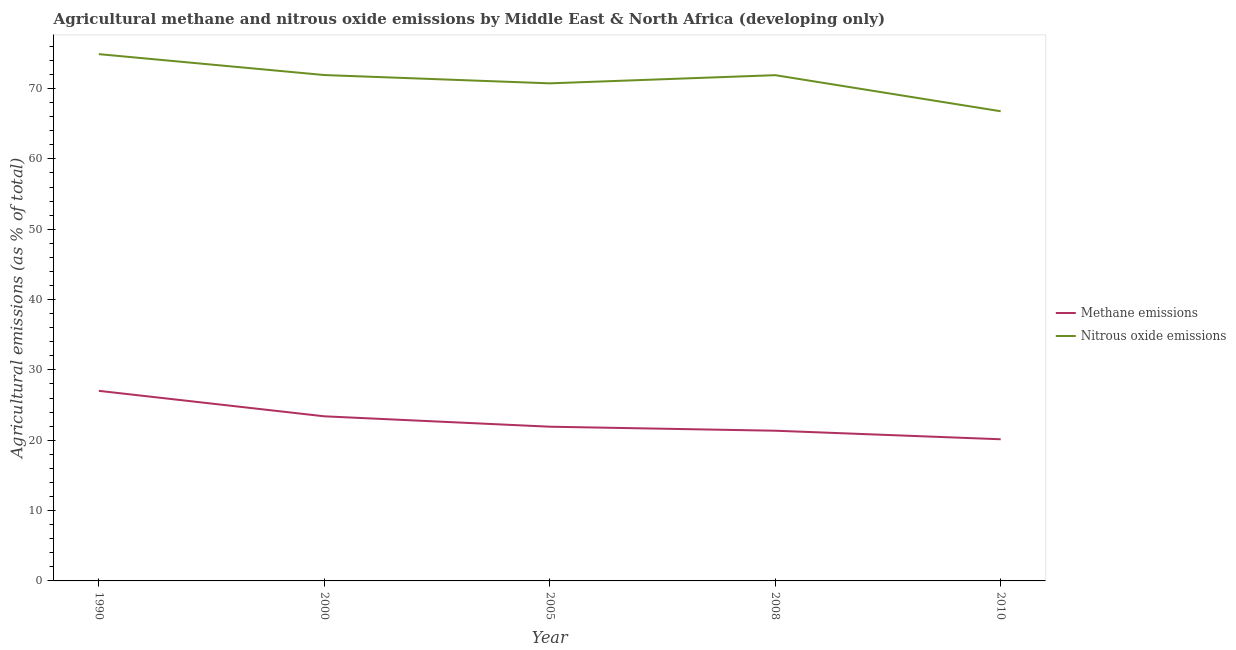How many different coloured lines are there?
Provide a short and direct response. 2. Is the number of lines equal to the number of legend labels?
Ensure brevity in your answer.  Yes. What is the amount of nitrous oxide emissions in 2008?
Ensure brevity in your answer.  71.9. Across all years, what is the maximum amount of nitrous oxide emissions?
Your answer should be compact. 74.9. Across all years, what is the minimum amount of methane emissions?
Ensure brevity in your answer.  20.14. What is the total amount of methane emissions in the graph?
Provide a short and direct response. 113.85. What is the difference between the amount of methane emissions in 2005 and that in 2008?
Ensure brevity in your answer.  0.57. What is the difference between the amount of methane emissions in 2010 and the amount of nitrous oxide emissions in 1990?
Ensure brevity in your answer.  -54.76. What is the average amount of methane emissions per year?
Ensure brevity in your answer.  22.77. In the year 2000, what is the difference between the amount of nitrous oxide emissions and amount of methane emissions?
Keep it short and to the point. 48.52. In how many years, is the amount of nitrous oxide emissions greater than 44 %?
Offer a very short reply. 5. What is the ratio of the amount of nitrous oxide emissions in 2000 to that in 2008?
Your answer should be very brief. 1. What is the difference between the highest and the second highest amount of nitrous oxide emissions?
Ensure brevity in your answer.  2.97. What is the difference between the highest and the lowest amount of methane emissions?
Offer a very short reply. 6.89. In how many years, is the amount of nitrous oxide emissions greater than the average amount of nitrous oxide emissions taken over all years?
Provide a succinct answer. 3. Is the amount of methane emissions strictly greater than the amount of nitrous oxide emissions over the years?
Keep it short and to the point. No. Is the amount of nitrous oxide emissions strictly less than the amount of methane emissions over the years?
Make the answer very short. No. How many lines are there?
Your response must be concise. 2. How many years are there in the graph?
Keep it short and to the point. 5. What is the difference between two consecutive major ticks on the Y-axis?
Provide a succinct answer. 10. Does the graph contain grids?
Provide a short and direct response. No. How are the legend labels stacked?
Keep it short and to the point. Vertical. What is the title of the graph?
Give a very brief answer. Agricultural methane and nitrous oxide emissions by Middle East & North Africa (developing only). Does "UN agencies" appear as one of the legend labels in the graph?
Make the answer very short. No. What is the label or title of the X-axis?
Your answer should be compact. Year. What is the label or title of the Y-axis?
Your answer should be very brief. Agricultural emissions (as % of total). What is the Agricultural emissions (as % of total) in Methane emissions in 1990?
Your response must be concise. 27.03. What is the Agricultural emissions (as % of total) of Nitrous oxide emissions in 1990?
Give a very brief answer. 74.9. What is the Agricultural emissions (as % of total) in Methane emissions in 2000?
Offer a very short reply. 23.4. What is the Agricultural emissions (as % of total) in Nitrous oxide emissions in 2000?
Ensure brevity in your answer.  71.92. What is the Agricultural emissions (as % of total) of Methane emissions in 2005?
Your answer should be very brief. 21.93. What is the Agricultural emissions (as % of total) in Nitrous oxide emissions in 2005?
Ensure brevity in your answer.  70.74. What is the Agricultural emissions (as % of total) of Methane emissions in 2008?
Ensure brevity in your answer.  21.36. What is the Agricultural emissions (as % of total) in Nitrous oxide emissions in 2008?
Keep it short and to the point. 71.9. What is the Agricultural emissions (as % of total) in Methane emissions in 2010?
Make the answer very short. 20.14. What is the Agricultural emissions (as % of total) in Nitrous oxide emissions in 2010?
Give a very brief answer. 66.77. Across all years, what is the maximum Agricultural emissions (as % of total) of Methane emissions?
Offer a very short reply. 27.03. Across all years, what is the maximum Agricultural emissions (as % of total) in Nitrous oxide emissions?
Provide a succinct answer. 74.9. Across all years, what is the minimum Agricultural emissions (as % of total) in Methane emissions?
Make the answer very short. 20.14. Across all years, what is the minimum Agricultural emissions (as % of total) in Nitrous oxide emissions?
Offer a terse response. 66.77. What is the total Agricultural emissions (as % of total) of Methane emissions in the graph?
Provide a short and direct response. 113.85. What is the total Agricultural emissions (as % of total) in Nitrous oxide emissions in the graph?
Ensure brevity in your answer.  356.24. What is the difference between the Agricultural emissions (as % of total) in Methane emissions in 1990 and that in 2000?
Your answer should be very brief. 3.62. What is the difference between the Agricultural emissions (as % of total) of Nitrous oxide emissions in 1990 and that in 2000?
Provide a succinct answer. 2.97. What is the difference between the Agricultural emissions (as % of total) of Methane emissions in 1990 and that in 2005?
Your answer should be compact. 5.1. What is the difference between the Agricultural emissions (as % of total) of Nitrous oxide emissions in 1990 and that in 2005?
Your answer should be very brief. 4.15. What is the difference between the Agricultural emissions (as % of total) in Methane emissions in 1990 and that in 2008?
Your response must be concise. 5.67. What is the difference between the Agricultural emissions (as % of total) of Nitrous oxide emissions in 1990 and that in 2008?
Provide a succinct answer. 2.99. What is the difference between the Agricultural emissions (as % of total) in Methane emissions in 1990 and that in 2010?
Your answer should be compact. 6.89. What is the difference between the Agricultural emissions (as % of total) in Nitrous oxide emissions in 1990 and that in 2010?
Your answer should be compact. 8.12. What is the difference between the Agricultural emissions (as % of total) in Methane emissions in 2000 and that in 2005?
Make the answer very short. 1.48. What is the difference between the Agricultural emissions (as % of total) of Nitrous oxide emissions in 2000 and that in 2005?
Keep it short and to the point. 1.18. What is the difference between the Agricultural emissions (as % of total) of Methane emissions in 2000 and that in 2008?
Your answer should be very brief. 2.05. What is the difference between the Agricultural emissions (as % of total) in Nitrous oxide emissions in 2000 and that in 2008?
Provide a short and direct response. 0.02. What is the difference between the Agricultural emissions (as % of total) in Methane emissions in 2000 and that in 2010?
Your response must be concise. 3.26. What is the difference between the Agricultural emissions (as % of total) of Nitrous oxide emissions in 2000 and that in 2010?
Ensure brevity in your answer.  5.15. What is the difference between the Agricultural emissions (as % of total) of Methane emissions in 2005 and that in 2008?
Provide a succinct answer. 0.57. What is the difference between the Agricultural emissions (as % of total) in Nitrous oxide emissions in 2005 and that in 2008?
Give a very brief answer. -1.16. What is the difference between the Agricultural emissions (as % of total) of Methane emissions in 2005 and that in 2010?
Provide a short and direct response. 1.79. What is the difference between the Agricultural emissions (as % of total) in Nitrous oxide emissions in 2005 and that in 2010?
Keep it short and to the point. 3.97. What is the difference between the Agricultural emissions (as % of total) of Methane emissions in 2008 and that in 2010?
Keep it short and to the point. 1.22. What is the difference between the Agricultural emissions (as % of total) in Nitrous oxide emissions in 2008 and that in 2010?
Provide a short and direct response. 5.13. What is the difference between the Agricultural emissions (as % of total) of Methane emissions in 1990 and the Agricultural emissions (as % of total) of Nitrous oxide emissions in 2000?
Offer a terse response. -44.9. What is the difference between the Agricultural emissions (as % of total) in Methane emissions in 1990 and the Agricultural emissions (as % of total) in Nitrous oxide emissions in 2005?
Provide a succinct answer. -43.72. What is the difference between the Agricultural emissions (as % of total) of Methane emissions in 1990 and the Agricultural emissions (as % of total) of Nitrous oxide emissions in 2008?
Provide a short and direct response. -44.88. What is the difference between the Agricultural emissions (as % of total) in Methane emissions in 1990 and the Agricultural emissions (as % of total) in Nitrous oxide emissions in 2010?
Your answer should be compact. -39.75. What is the difference between the Agricultural emissions (as % of total) of Methane emissions in 2000 and the Agricultural emissions (as % of total) of Nitrous oxide emissions in 2005?
Keep it short and to the point. -47.34. What is the difference between the Agricultural emissions (as % of total) of Methane emissions in 2000 and the Agricultural emissions (as % of total) of Nitrous oxide emissions in 2008?
Keep it short and to the point. -48.5. What is the difference between the Agricultural emissions (as % of total) in Methane emissions in 2000 and the Agricultural emissions (as % of total) in Nitrous oxide emissions in 2010?
Offer a very short reply. -43.37. What is the difference between the Agricultural emissions (as % of total) of Methane emissions in 2005 and the Agricultural emissions (as % of total) of Nitrous oxide emissions in 2008?
Your answer should be very brief. -49.98. What is the difference between the Agricultural emissions (as % of total) in Methane emissions in 2005 and the Agricultural emissions (as % of total) in Nitrous oxide emissions in 2010?
Give a very brief answer. -44.85. What is the difference between the Agricultural emissions (as % of total) in Methane emissions in 2008 and the Agricultural emissions (as % of total) in Nitrous oxide emissions in 2010?
Keep it short and to the point. -45.42. What is the average Agricultural emissions (as % of total) of Methane emissions per year?
Offer a terse response. 22.77. What is the average Agricultural emissions (as % of total) in Nitrous oxide emissions per year?
Your answer should be compact. 71.25. In the year 1990, what is the difference between the Agricultural emissions (as % of total) of Methane emissions and Agricultural emissions (as % of total) of Nitrous oxide emissions?
Provide a short and direct response. -47.87. In the year 2000, what is the difference between the Agricultural emissions (as % of total) of Methane emissions and Agricultural emissions (as % of total) of Nitrous oxide emissions?
Your answer should be very brief. -48.52. In the year 2005, what is the difference between the Agricultural emissions (as % of total) of Methane emissions and Agricultural emissions (as % of total) of Nitrous oxide emissions?
Provide a succinct answer. -48.82. In the year 2008, what is the difference between the Agricultural emissions (as % of total) in Methane emissions and Agricultural emissions (as % of total) in Nitrous oxide emissions?
Your response must be concise. -50.55. In the year 2010, what is the difference between the Agricultural emissions (as % of total) in Methane emissions and Agricultural emissions (as % of total) in Nitrous oxide emissions?
Your response must be concise. -46.63. What is the ratio of the Agricultural emissions (as % of total) in Methane emissions in 1990 to that in 2000?
Offer a terse response. 1.15. What is the ratio of the Agricultural emissions (as % of total) of Nitrous oxide emissions in 1990 to that in 2000?
Give a very brief answer. 1.04. What is the ratio of the Agricultural emissions (as % of total) in Methane emissions in 1990 to that in 2005?
Ensure brevity in your answer.  1.23. What is the ratio of the Agricultural emissions (as % of total) of Nitrous oxide emissions in 1990 to that in 2005?
Ensure brevity in your answer.  1.06. What is the ratio of the Agricultural emissions (as % of total) in Methane emissions in 1990 to that in 2008?
Make the answer very short. 1.27. What is the ratio of the Agricultural emissions (as % of total) in Nitrous oxide emissions in 1990 to that in 2008?
Make the answer very short. 1.04. What is the ratio of the Agricultural emissions (as % of total) of Methane emissions in 1990 to that in 2010?
Your answer should be very brief. 1.34. What is the ratio of the Agricultural emissions (as % of total) in Nitrous oxide emissions in 1990 to that in 2010?
Offer a very short reply. 1.12. What is the ratio of the Agricultural emissions (as % of total) of Methane emissions in 2000 to that in 2005?
Keep it short and to the point. 1.07. What is the ratio of the Agricultural emissions (as % of total) of Nitrous oxide emissions in 2000 to that in 2005?
Provide a short and direct response. 1.02. What is the ratio of the Agricultural emissions (as % of total) in Methane emissions in 2000 to that in 2008?
Your answer should be compact. 1.1. What is the ratio of the Agricultural emissions (as % of total) in Nitrous oxide emissions in 2000 to that in 2008?
Offer a very short reply. 1. What is the ratio of the Agricultural emissions (as % of total) in Methane emissions in 2000 to that in 2010?
Offer a very short reply. 1.16. What is the ratio of the Agricultural emissions (as % of total) of Nitrous oxide emissions in 2000 to that in 2010?
Make the answer very short. 1.08. What is the ratio of the Agricultural emissions (as % of total) of Methane emissions in 2005 to that in 2008?
Provide a short and direct response. 1.03. What is the ratio of the Agricultural emissions (as % of total) of Nitrous oxide emissions in 2005 to that in 2008?
Your answer should be compact. 0.98. What is the ratio of the Agricultural emissions (as % of total) of Methane emissions in 2005 to that in 2010?
Your answer should be very brief. 1.09. What is the ratio of the Agricultural emissions (as % of total) in Nitrous oxide emissions in 2005 to that in 2010?
Your response must be concise. 1.06. What is the ratio of the Agricultural emissions (as % of total) of Methane emissions in 2008 to that in 2010?
Your answer should be compact. 1.06. What is the ratio of the Agricultural emissions (as % of total) in Nitrous oxide emissions in 2008 to that in 2010?
Provide a short and direct response. 1.08. What is the difference between the highest and the second highest Agricultural emissions (as % of total) of Methane emissions?
Offer a very short reply. 3.62. What is the difference between the highest and the second highest Agricultural emissions (as % of total) in Nitrous oxide emissions?
Make the answer very short. 2.97. What is the difference between the highest and the lowest Agricultural emissions (as % of total) in Methane emissions?
Your response must be concise. 6.89. What is the difference between the highest and the lowest Agricultural emissions (as % of total) of Nitrous oxide emissions?
Provide a succinct answer. 8.12. 